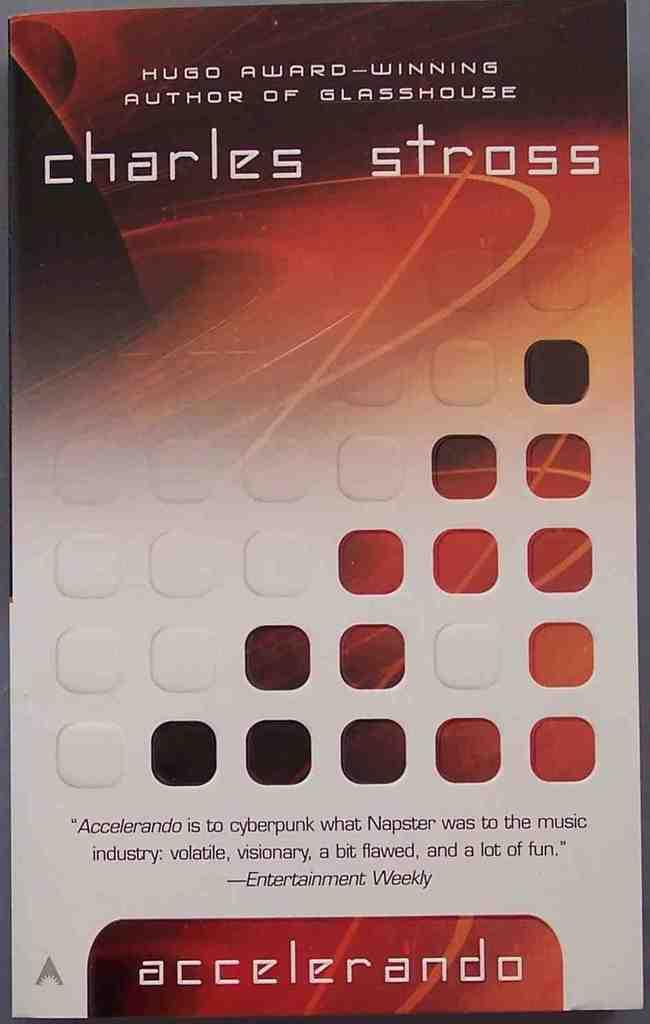<image>
Give a short and clear explanation of the subsequent image. charles stross is mentioned in an ad for accelerando 